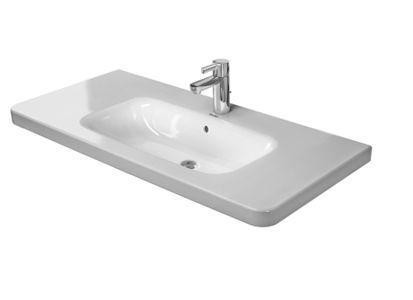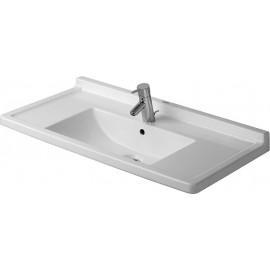The first image is the image on the left, the second image is the image on the right. For the images displayed, is the sentence "Each sink is a single-basin design inset in a white rectangle that is straight across the front." factually correct? Answer yes or no. Yes. 